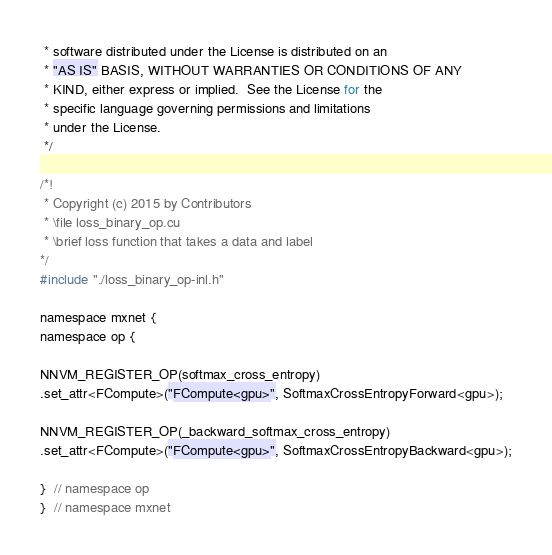<code> <loc_0><loc_0><loc_500><loc_500><_Cuda_> * software distributed under the License is distributed on an
 * "AS IS" BASIS, WITHOUT WARRANTIES OR CONDITIONS OF ANY
 * KIND, either express or implied.  See the License for the
 * specific language governing permissions and limitations
 * under the License.
 */

/*!
 * Copyright (c) 2015 by Contributors
 * \file loss_binary_op.cu
 * \brief loss function that takes a data and label
*/
#include "./loss_binary_op-inl.h"

namespace mxnet {
namespace op {

NNVM_REGISTER_OP(softmax_cross_entropy)
.set_attr<FCompute>("FCompute<gpu>", SoftmaxCrossEntropyForward<gpu>);

NNVM_REGISTER_OP(_backward_softmax_cross_entropy)
.set_attr<FCompute>("FCompute<gpu>", SoftmaxCrossEntropyBackward<gpu>);

}  // namespace op
}  // namespace mxnet
</code> 